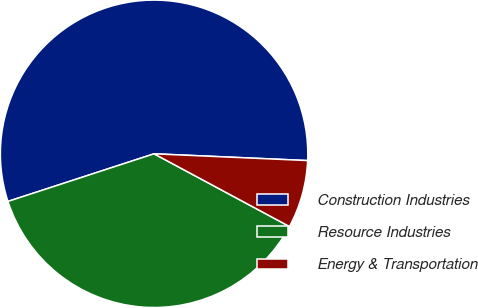Convert chart to OTSL. <chart><loc_0><loc_0><loc_500><loc_500><pie_chart><fcel>Construction Industries<fcel>Resource Industries<fcel>Energy & Transportation<nl><fcel>55.71%<fcel>37.14%<fcel>7.14%<nl></chart> 